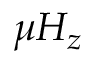Convert formula to latex. <formula><loc_0><loc_0><loc_500><loc_500>\mu H _ { z }</formula> 